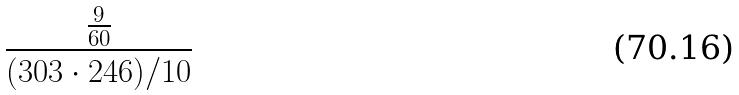Convert formula to latex. <formula><loc_0><loc_0><loc_500><loc_500>\frac { \frac { 9 } { 6 0 } } { ( 3 0 3 \cdot 2 4 6 ) / 1 0 }</formula> 